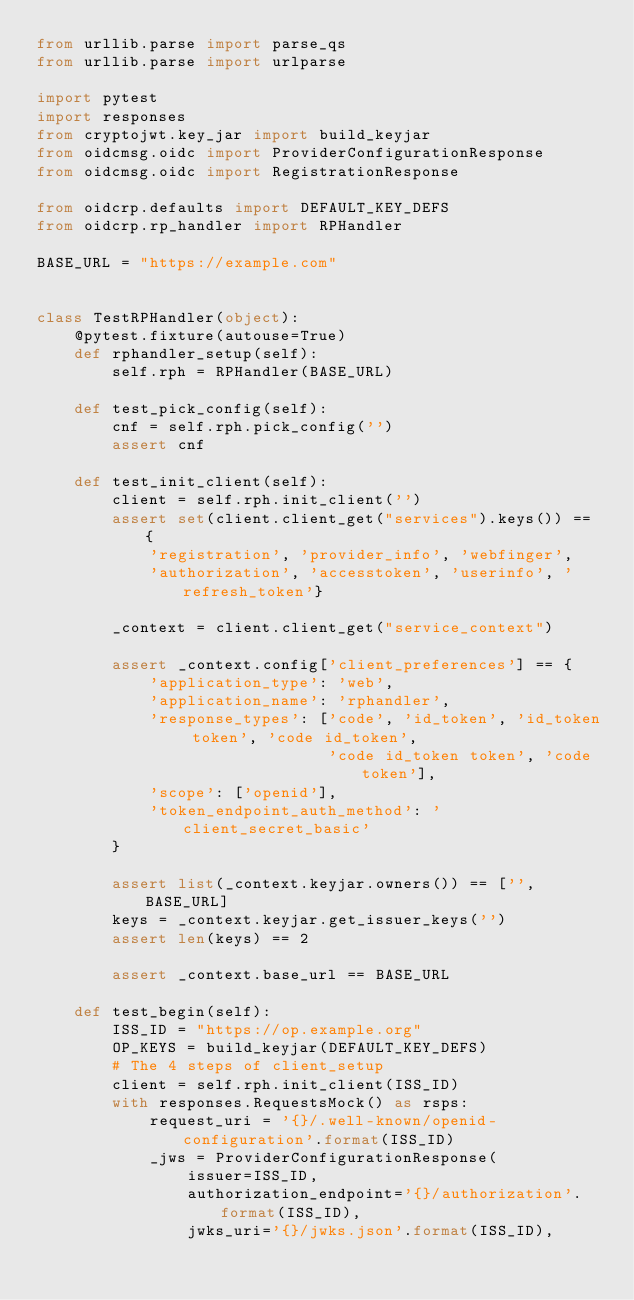Convert code to text. <code><loc_0><loc_0><loc_500><loc_500><_Python_>from urllib.parse import parse_qs
from urllib.parse import urlparse

import pytest
import responses
from cryptojwt.key_jar import build_keyjar
from oidcmsg.oidc import ProviderConfigurationResponse
from oidcmsg.oidc import RegistrationResponse

from oidcrp.defaults import DEFAULT_KEY_DEFS
from oidcrp.rp_handler import RPHandler

BASE_URL = "https://example.com"


class TestRPHandler(object):
    @pytest.fixture(autouse=True)
    def rphandler_setup(self):
        self.rph = RPHandler(BASE_URL)

    def test_pick_config(self):
        cnf = self.rph.pick_config('')
        assert cnf

    def test_init_client(self):
        client = self.rph.init_client('')
        assert set(client.client_get("services").keys()) == {
            'registration', 'provider_info', 'webfinger',
            'authorization', 'accesstoken', 'userinfo', 'refresh_token'}

        _context = client.client_get("service_context")

        assert _context.config['client_preferences'] == {
            'application_type': 'web',
            'application_name': 'rphandler',
            'response_types': ['code', 'id_token', 'id_token token', 'code id_token',
                               'code id_token token', 'code token'],
            'scope': ['openid'],
            'token_endpoint_auth_method': 'client_secret_basic'
        }

        assert list(_context.keyjar.owners()) == ['', BASE_URL]
        keys = _context.keyjar.get_issuer_keys('')
        assert len(keys) == 2

        assert _context.base_url == BASE_URL

    def test_begin(self):
        ISS_ID = "https://op.example.org"
        OP_KEYS = build_keyjar(DEFAULT_KEY_DEFS)
        # The 4 steps of client_setup
        client = self.rph.init_client(ISS_ID)
        with responses.RequestsMock() as rsps:
            request_uri = '{}/.well-known/openid-configuration'.format(ISS_ID)
            _jws = ProviderConfigurationResponse(
                issuer=ISS_ID,
                authorization_endpoint='{}/authorization'.format(ISS_ID),
                jwks_uri='{}/jwks.json'.format(ISS_ID),</code> 